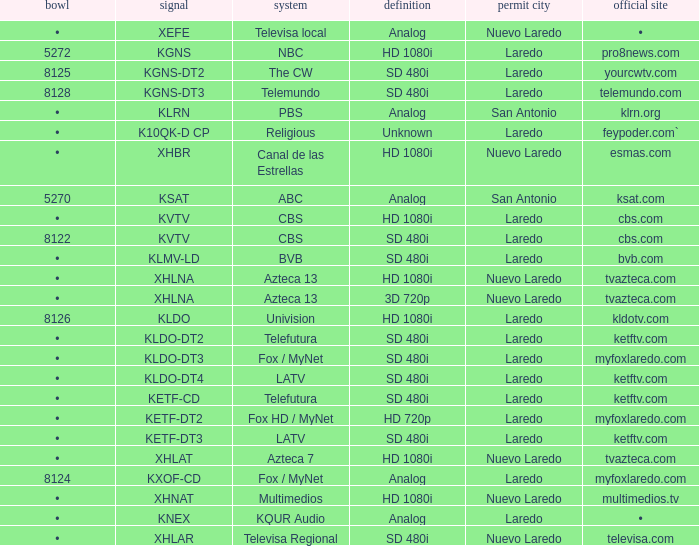Name the resolution for dish of 5270 Analog. 